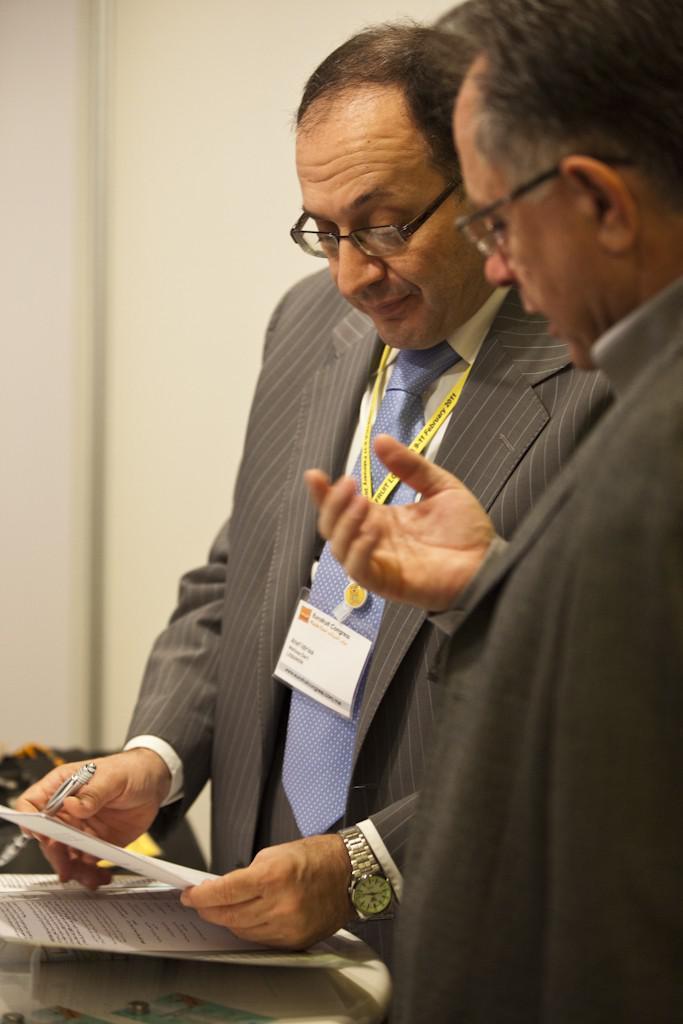Describe this image in one or two sentences. In this image I can see few persons wearing blazers are standing and I can see a person wearing a watch and holding a paper and pen in his hands. I can see few papers and few other objects. In the background I can see the white colored wall. 